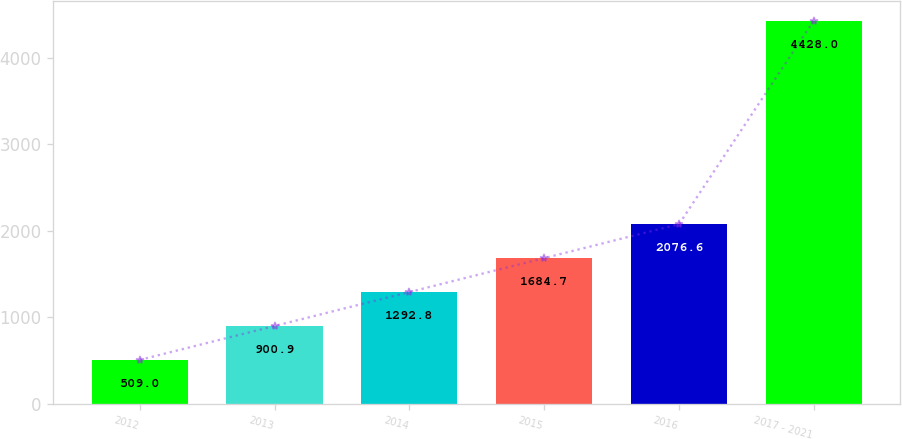<chart> <loc_0><loc_0><loc_500><loc_500><bar_chart><fcel>2012<fcel>2013<fcel>2014<fcel>2015<fcel>2016<fcel>2017 - 2021<nl><fcel>509<fcel>900.9<fcel>1292.8<fcel>1684.7<fcel>2076.6<fcel>4428<nl></chart> 